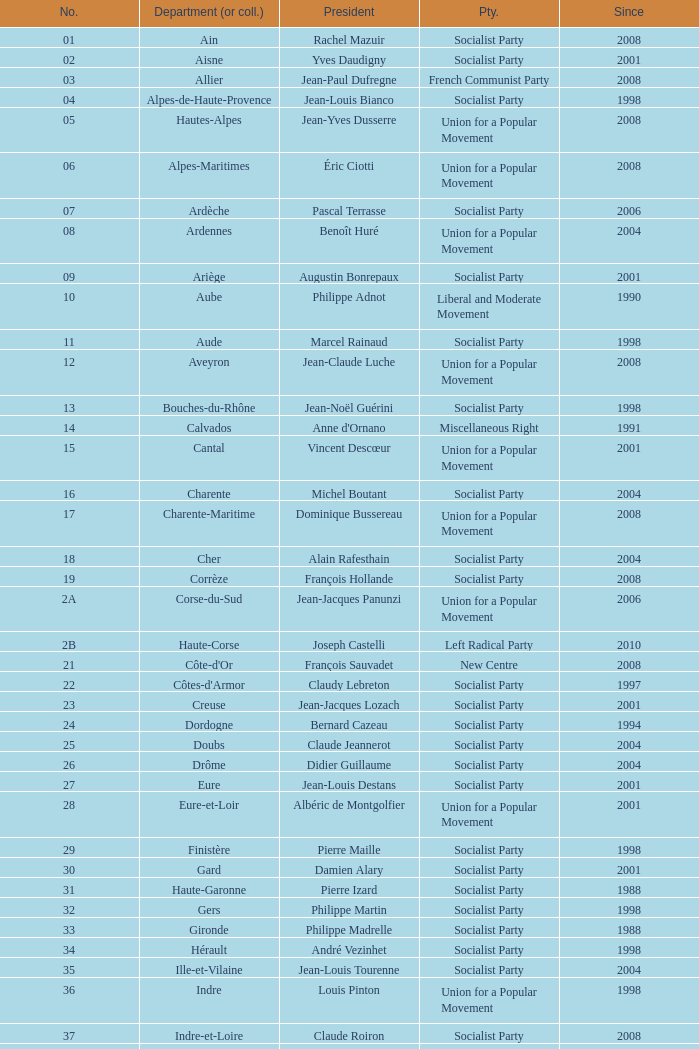Which department has Guy-Dominique Kennel as president since 2008? Bas-Rhin. 